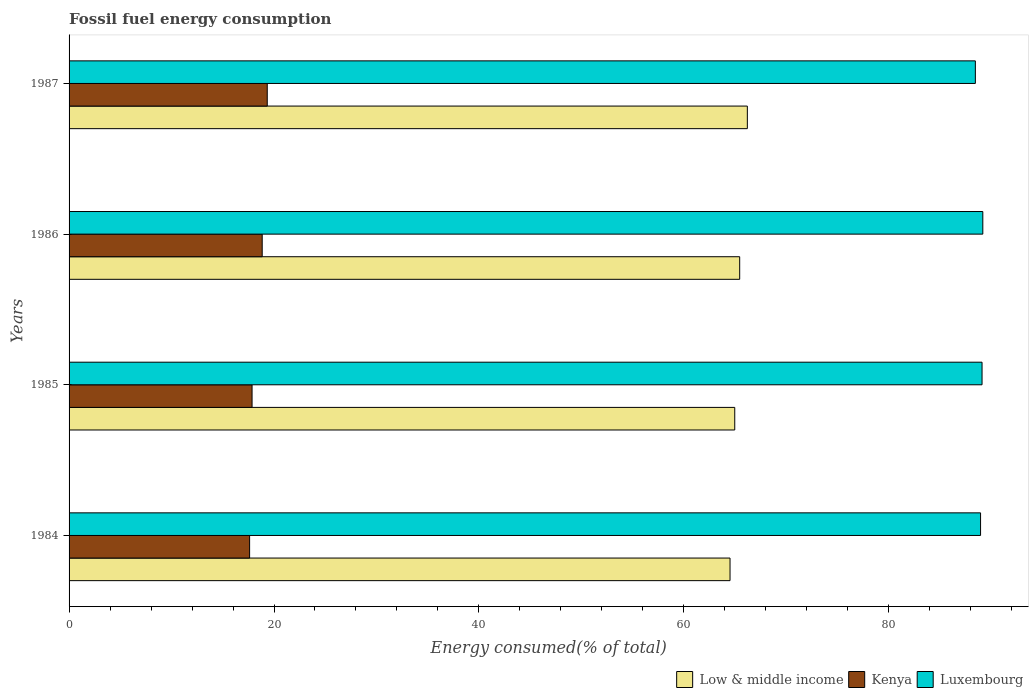How many groups of bars are there?
Your answer should be compact. 4. Are the number of bars per tick equal to the number of legend labels?
Provide a succinct answer. Yes. Are the number of bars on each tick of the Y-axis equal?
Make the answer very short. Yes. How many bars are there on the 4th tick from the top?
Your response must be concise. 3. What is the label of the 1st group of bars from the top?
Give a very brief answer. 1987. In how many cases, is the number of bars for a given year not equal to the number of legend labels?
Offer a very short reply. 0. What is the percentage of energy consumed in Luxembourg in 1987?
Provide a succinct answer. 88.45. Across all years, what is the maximum percentage of energy consumed in Kenya?
Make the answer very short. 19.34. Across all years, what is the minimum percentage of energy consumed in Low & middle income?
Your answer should be very brief. 64.51. In which year was the percentage of energy consumed in Kenya minimum?
Keep it short and to the point. 1984. What is the total percentage of energy consumed in Low & middle income in the graph?
Make the answer very short. 261.12. What is the difference between the percentage of energy consumed in Kenya in 1984 and that in 1985?
Your response must be concise. -0.24. What is the difference between the percentage of energy consumed in Kenya in 1985 and the percentage of energy consumed in Luxembourg in 1986?
Your answer should be very brief. -71.32. What is the average percentage of energy consumed in Kenya per year?
Provide a succinct answer. 18.42. In the year 1984, what is the difference between the percentage of energy consumed in Luxembourg and percentage of energy consumed in Kenya?
Offer a terse response. 71.34. In how many years, is the percentage of energy consumed in Luxembourg greater than 32 %?
Provide a succinct answer. 4. What is the ratio of the percentage of energy consumed in Low & middle income in 1985 to that in 1986?
Your answer should be very brief. 0.99. Is the difference between the percentage of energy consumed in Luxembourg in 1984 and 1986 greater than the difference between the percentage of energy consumed in Kenya in 1984 and 1986?
Give a very brief answer. Yes. What is the difference between the highest and the second highest percentage of energy consumed in Low & middle income?
Your answer should be compact. 0.75. What is the difference between the highest and the lowest percentage of energy consumed in Kenya?
Make the answer very short. 1.72. Is the sum of the percentage of energy consumed in Luxembourg in 1985 and 1987 greater than the maximum percentage of energy consumed in Low & middle income across all years?
Provide a succinct answer. Yes. What does the 3rd bar from the bottom in 1984 represents?
Offer a terse response. Luxembourg. Are all the bars in the graph horizontal?
Your answer should be very brief. Yes. How many years are there in the graph?
Your answer should be compact. 4. Are the values on the major ticks of X-axis written in scientific E-notation?
Offer a very short reply. No. Does the graph contain grids?
Offer a very short reply. No. How many legend labels are there?
Make the answer very short. 3. How are the legend labels stacked?
Provide a succinct answer. Horizontal. What is the title of the graph?
Ensure brevity in your answer.  Fossil fuel energy consumption. What is the label or title of the X-axis?
Offer a terse response. Energy consumed(% of total). What is the label or title of the Y-axis?
Make the answer very short. Years. What is the Energy consumed(% of total) of Low & middle income in 1984?
Offer a terse response. 64.51. What is the Energy consumed(% of total) in Kenya in 1984?
Give a very brief answer. 17.62. What is the Energy consumed(% of total) in Luxembourg in 1984?
Keep it short and to the point. 88.96. What is the Energy consumed(% of total) of Low & middle income in 1985?
Offer a terse response. 64.97. What is the Energy consumed(% of total) of Kenya in 1985?
Ensure brevity in your answer.  17.86. What is the Energy consumed(% of total) of Luxembourg in 1985?
Provide a short and direct response. 89.1. What is the Energy consumed(% of total) in Low & middle income in 1986?
Make the answer very short. 65.45. What is the Energy consumed(% of total) in Kenya in 1986?
Offer a very short reply. 18.85. What is the Energy consumed(% of total) of Luxembourg in 1986?
Give a very brief answer. 89.18. What is the Energy consumed(% of total) of Low & middle income in 1987?
Ensure brevity in your answer.  66.2. What is the Energy consumed(% of total) of Kenya in 1987?
Your answer should be compact. 19.34. What is the Energy consumed(% of total) in Luxembourg in 1987?
Make the answer very short. 88.45. Across all years, what is the maximum Energy consumed(% of total) of Low & middle income?
Your answer should be compact. 66.2. Across all years, what is the maximum Energy consumed(% of total) in Kenya?
Offer a terse response. 19.34. Across all years, what is the maximum Energy consumed(% of total) in Luxembourg?
Give a very brief answer. 89.18. Across all years, what is the minimum Energy consumed(% of total) in Low & middle income?
Your response must be concise. 64.51. Across all years, what is the minimum Energy consumed(% of total) in Kenya?
Ensure brevity in your answer.  17.62. Across all years, what is the minimum Energy consumed(% of total) in Luxembourg?
Offer a very short reply. 88.45. What is the total Energy consumed(% of total) in Low & middle income in the graph?
Offer a very short reply. 261.12. What is the total Energy consumed(% of total) in Kenya in the graph?
Your answer should be compact. 73.67. What is the total Energy consumed(% of total) in Luxembourg in the graph?
Provide a succinct answer. 355.69. What is the difference between the Energy consumed(% of total) of Low & middle income in 1984 and that in 1985?
Your answer should be very brief. -0.46. What is the difference between the Energy consumed(% of total) of Kenya in 1984 and that in 1985?
Your response must be concise. -0.24. What is the difference between the Energy consumed(% of total) in Luxembourg in 1984 and that in 1985?
Give a very brief answer. -0.14. What is the difference between the Energy consumed(% of total) in Low & middle income in 1984 and that in 1986?
Ensure brevity in your answer.  -0.94. What is the difference between the Energy consumed(% of total) of Kenya in 1984 and that in 1986?
Make the answer very short. -1.23. What is the difference between the Energy consumed(% of total) in Luxembourg in 1984 and that in 1986?
Your response must be concise. -0.22. What is the difference between the Energy consumed(% of total) of Low & middle income in 1984 and that in 1987?
Offer a terse response. -1.69. What is the difference between the Energy consumed(% of total) of Kenya in 1984 and that in 1987?
Offer a terse response. -1.72. What is the difference between the Energy consumed(% of total) in Luxembourg in 1984 and that in 1987?
Make the answer very short. 0.51. What is the difference between the Energy consumed(% of total) in Low & middle income in 1985 and that in 1986?
Your answer should be compact. -0.48. What is the difference between the Energy consumed(% of total) of Kenya in 1985 and that in 1986?
Keep it short and to the point. -0.99. What is the difference between the Energy consumed(% of total) in Luxembourg in 1985 and that in 1986?
Ensure brevity in your answer.  -0.07. What is the difference between the Energy consumed(% of total) in Low & middle income in 1985 and that in 1987?
Keep it short and to the point. -1.23. What is the difference between the Energy consumed(% of total) in Kenya in 1985 and that in 1987?
Provide a succinct answer. -1.48. What is the difference between the Energy consumed(% of total) of Luxembourg in 1985 and that in 1987?
Give a very brief answer. 0.65. What is the difference between the Energy consumed(% of total) of Low & middle income in 1986 and that in 1987?
Provide a succinct answer. -0.75. What is the difference between the Energy consumed(% of total) in Kenya in 1986 and that in 1987?
Offer a terse response. -0.49. What is the difference between the Energy consumed(% of total) of Luxembourg in 1986 and that in 1987?
Your answer should be very brief. 0.73. What is the difference between the Energy consumed(% of total) of Low & middle income in 1984 and the Energy consumed(% of total) of Kenya in 1985?
Give a very brief answer. 46.65. What is the difference between the Energy consumed(% of total) of Low & middle income in 1984 and the Energy consumed(% of total) of Luxembourg in 1985?
Ensure brevity in your answer.  -24.6. What is the difference between the Energy consumed(% of total) of Kenya in 1984 and the Energy consumed(% of total) of Luxembourg in 1985?
Provide a succinct answer. -71.48. What is the difference between the Energy consumed(% of total) in Low & middle income in 1984 and the Energy consumed(% of total) in Kenya in 1986?
Your response must be concise. 45.66. What is the difference between the Energy consumed(% of total) of Low & middle income in 1984 and the Energy consumed(% of total) of Luxembourg in 1986?
Make the answer very short. -24.67. What is the difference between the Energy consumed(% of total) in Kenya in 1984 and the Energy consumed(% of total) in Luxembourg in 1986?
Provide a short and direct response. -71.56. What is the difference between the Energy consumed(% of total) in Low & middle income in 1984 and the Energy consumed(% of total) in Kenya in 1987?
Provide a succinct answer. 45.17. What is the difference between the Energy consumed(% of total) of Low & middle income in 1984 and the Energy consumed(% of total) of Luxembourg in 1987?
Provide a succinct answer. -23.94. What is the difference between the Energy consumed(% of total) of Kenya in 1984 and the Energy consumed(% of total) of Luxembourg in 1987?
Keep it short and to the point. -70.83. What is the difference between the Energy consumed(% of total) of Low & middle income in 1985 and the Energy consumed(% of total) of Kenya in 1986?
Offer a very short reply. 46.12. What is the difference between the Energy consumed(% of total) of Low & middle income in 1985 and the Energy consumed(% of total) of Luxembourg in 1986?
Make the answer very short. -24.21. What is the difference between the Energy consumed(% of total) of Kenya in 1985 and the Energy consumed(% of total) of Luxembourg in 1986?
Your answer should be very brief. -71.32. What is the difference between the Energy consumed(% of total) of Low & middle income in 1985 and the Energy consumed(% of total) of Kenya in 1987?
Offer a terse response. 45.62. What is the difference between the Energy consumed(% of total) in Low & middle income in 1985 and the Energy consumed(% of total) in Luxembourg in 1987?
Make the answer very short. -23.48. What is the difference between the Energy consumed(% of total) in Kenya in 1985 and the Energy consumed(% of total) in Luxembourg in 1987?
Ensure brevity in your answer.  -70.59. What is the difference between the Energy consumed(% of total) of Low & middle income in 1986 and the Energy consumed(% of total) of Kenya in 1987?
Keep it short and to the point. 46.11. What is the difference between the Energy consumed(% of total) in Low & middle income in 1986 and the Energy consumed(% of total) in Luxembourg in 1987?
Give a very brief answer. -23. What is the difference between the Energy consumed(% of total) in Kenya in 1986 and the Energy consumed(% of total) in Luxembourg in 1987?
Ensure brevity in your answer.  -69.6. What is the average Energy consumed(% of total) of Low & middle income per year?
Make the answer very short. 65.28. What is the average Energy consumed(% of total) of Kenya per year?
Offer a very short reply. 18.42. What is the average Energy consumed(% of total) of Luxembourg per year?
Your answer should be compact. 88.92. In the year 1984, what is the difference between the Energy consumed(% of total) in Low & middle income and Energy consumed(% of total) in Kenya?
Your response must be concise. 46.89. In the year 1984, what is the difference between the Energy consumed(% of total) in Low & middle income and Energy consumed(% of total) in Luxembourg?
Provide a short and direct response. -24.45. In the year 1984, what is the difference between the Energy consumed(% of total) in Kenya and Energy consumed(% of total) in Luxembourg?
Your response must be concise. -71.34. In the year 1985, what is the difference between the Energy consumed(% of total) in Low & middle income and Energy consumed(% of total) in Kenya?
Ensure brevity in your answer.  47.11. In the year 1985, what is the difference between the Energy consumed(% of total) of Low & middle income and Energy consumed(% of total) of Luxembourg?
Ensure brevity in your answer.  -24.14. In the year 1985, what is the difference between the Energy consumed(% of total) in Kenya and Energy consumed(% of total) in Luxembourg?
Make the answer very short. -71.24. In the year 1986, what is the difference between the Energy consumed(% of total) in Low & middle income and Energy consumed(% of total) in Kenya?
Offer a terse response. 46.6. In the year 1986, what is the difference between the Energy consumed(% of total) of Low & middle income and Energy consumed(% of total) of Luxembourg?
Provide a short and direct response. -23.73. In the year 1986, what is the difference between the Energy consumed(% of total) in Kenya and Energy consumed(% of total) in Luxembourg?
Provide a succinct answer. -70.33. In the year 1987, what is the difference between the Energy consumed(% of total) of Low & middle income and Energy consumed(% of total) of Kenya?
Your answer should be compact. 46.85. In the year 1987, what is the difference between the Energy consumed(% of total) in Low & middle income and Energy consumed(% of total) in Luxembourg?
Offer a very short reply. -22.25. In the year 1987, what is the difference between the Energy consumed(% of total) of Kenya and Energy consumed(% of total) of Luxembourg?
Give a very brief answer. -69.11. What is the ratio of the Energy consumed(% of total) in Low & middle income in 1984 to that in 1985?
Offer a terse response. 0.99. What is the ratio of the Energy consumed(% of total) of Kenya in 1984 to that in 1985?
Keep it short and to the point. 0.99. What is the ratio of the Energy consumed(% of total) in Luxembourg in 1984 to that in 1985?
Your answer should be compact. 1. What is the ratio of the Energy consumed(% of total) in Low & middle income in 1984 to that in 1986?
Provide a succinct answer. 0.99. What is the ratio of the Energy consumed(% of total) of Kenya in 1984 to that in 1986?
Your response must be concise. 0.93. What is the ratio of the Energy consumed(% of total) in Luxembourg in 1984 to that in 1986?
Give a very brief answer. 1. What is the ratio of the Energy consumed(% of total) in Low & middle income in 1984 to that in 1987?
Ensure brevity in your answer.  0.97. What is the ratio of the Energy consumed(% of total) of Kenya in 1984 to that in 1987?
Your answer should be compact. 0.91. What is the ratio of the Energy consumed(% of total) in Kenya in 1985 to that in 1986?
Make the answer very short. 0.95. What is the ratio of the Energy consumed(% of total) of Luxembourg in 1985 to that in 1986?
Your response must be concise. 1. What is the ratio of the Energy consumed(% of total) in Low & middle income in 1985 to that in 1987?
Keep it short and to the point. 0.98. What is the ratio of the Energy consumed(% of total) in Kenya in 1985 to that in 1987?
Give a very brief answer. 0.92. What is the ratio of the Energy consumed(% of total) of Luxembourg in 1985 to that in 1987?
Keep it short and to the point. 1.01. What is the ratio of the Energy consumed(% of total) in Low & middle income in 1986 to that in 1987?
Provide a succinct answer. 0.99. What is the ratio of the Energy consumed(% of total) of Kenya in 1986 to that in 1987?
Your response must be concise. 0.97. What is the ratio of the Energy consumed(% of total) in Luxembourg in 1986 to that in 1987?
Keep it short and to the point. 1.01. What is the difference between the highest and the second highest Energy consumed(% of total) of Low & middle income?
Provide a short and direct response. 0.75. What is the difference between the highest and the second highest Energy consumed(% of total) in Kenya?
Your answer should be compact. 0.49. What is the difference between the highest and the second highest Energy consumed(% of total) in Luxembourg?
Offer a terse response. 0.07. What is the difference between the highest and the lowest Energy consumed(% of total) of Low & middle income?
Your answer should be very brief. 1.69. What is the difference between the highest and the lowest Energy consumed(% of total) of Kenya?
Provide a short and direct response. 1.72. What is the difference between the highest and the lowest Energy consumed(% of total) in Luxembourg?
Ensure brevity in your answer.  0.73. 